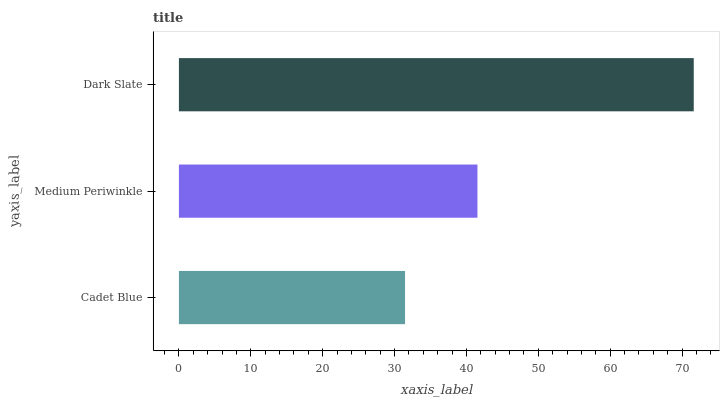Is Cadet Blue the minimum?
Answer yes or no. Yes. Is Dark Slate the maximum?
Answer yes or no. Yes. Is Medium Periwinkle the minimum?
Answer yes or no. No. Is Medium Periwinkle the maximum?
Answer yes or no. No. Is Medium Periwinkle greater than Cadet Blue?
Answer yes or no. Yes. Is Cadet Blue less than Medium Periwinkle?
Answer yes or no. Yes. Is Cadet Blue greater than Medium Periwinkle?
Answer yes or no. No. Is Medium Periwinkle less than Cadet Blue?
Answer yes or no. No. Is Medium Periwinkle the high median?
Answer yes or no. Yes. Is Medium Periwinkle the low median?
Answer yes or no. Yes. Is Cadet Blue the high median?
Answer yes or no. No. Is Dark Slate the low median?
Answer yes or no. No. 